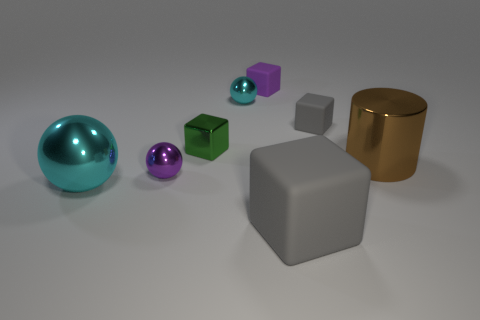Add 1 small purple matte objects. How many objects exist? 9 Subtract all green blocks. How many blocks are left? 3 Subtract all metallic blocks. How many blocks are left? 3 Subtract all brown blocks. Subtract all gray cylinders. How many blocks are left? 4 Subtract all cylinders. How many objects are left? 7 Add 4 large blue cylinders. How many large blue cylinders exist? 4 Subtract 1 green cubes. How many objects are left? 7 Subtract all tiny purple matte objects. Subtract all small purple shiny spheres. How many objects are left? 6 Add 1 tiny matte cubes. How many tiny matte cubes are left? 3 